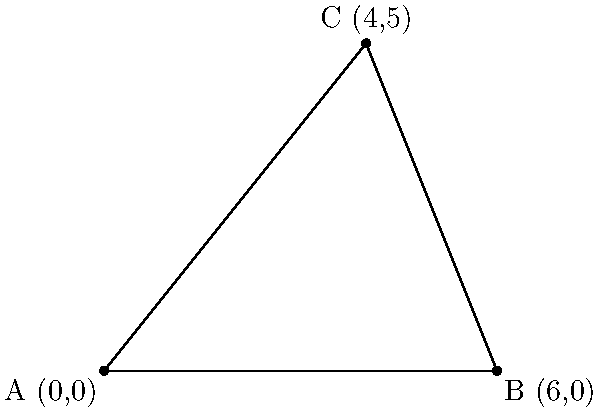A historical treaty defines the boundaries of tribal land using three coordinate points: A(0,0), B(6,0), and C(4,5). Calculate the area of this triangular piece of land in square units. To calculate the area of the triangular tribal land, we can use the formula for the area of a triangle given the coordinates of its vertices:

$$ \text{Area} = \frac{1}{2}|x_1(y_2 - y_3) + x_2(y_3 - y_1) + x_3(y_1 - y_2)| $$

Where $(x_1, y_1)$, $(x_2, y_2)$, and $(x_3, y_3)$ are the coordinates of the three vertices.

Given:
A(0,0), B(6,0), C(4,5)

Step 1: Substitute the coordinates into the formula:
$$ \text{Area} = \frac{1}{2}|0(0 - 5) + 6(5 - 0) + 4(0 - 0)| $$

Step 2: Simplify:
$$ \text{Area} = \frac{1}{2}|0 + 30 + 0| $$

Step 3: Calculate:
$$ \text{Area} = \frac{1}{2}(30) = 15 $$

Therefore, the area of the tribal land is 15 square units.
Answer: 15 square units 